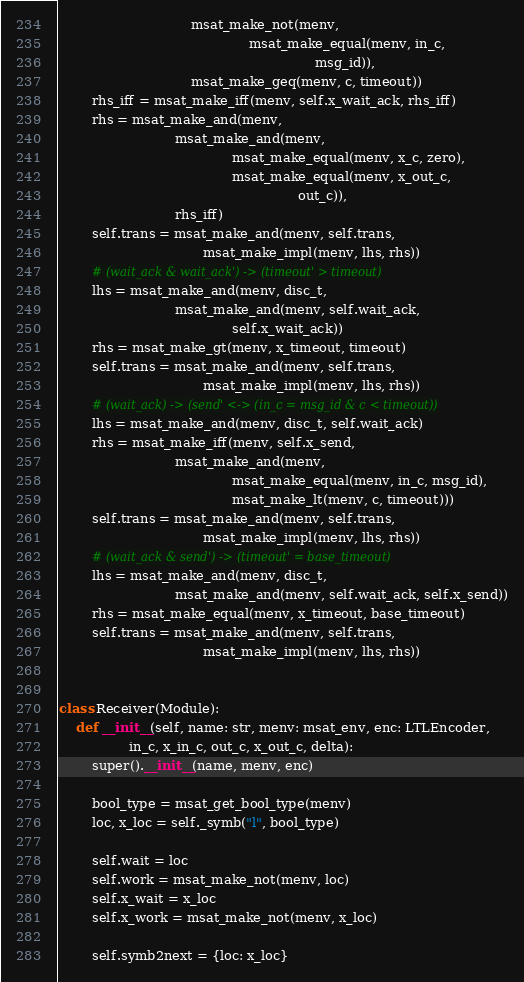Convert code to text. <code><loc_0><loc_0><loc_500><loc_500><_Python_>                                msat_make_not(menv,
                                              msat_make_equal(menv, in_c,
                                                              msg_id)),
                                msat_make_geq(menv, c, timeout))
        rhs_iff = msat_make_iff(menv, self.x_wait_ack, rhs_iff)
        rhs = msat_make_and(menv,
                            msat_make_and(menv,
                                          msat_make_equal(menv, x_c, zero),
                                          msat_make_equal(menv, x_out_c,
                                                          out_c)),
                            rhs_iff)
        self.trans = msat_make_and(menv, self.trans,
                                   msat_make_impl(menv, lhs, rhs))
        # (wait_ack & wait_ack') -> (timeout' > timeout)
        lhs = msat_make_and(menv, disc_t,
                            msat_make_and(menv, self.wait_ack,
                                          self.x_wait_ack))
        rhs = msat_make_gt(menv, x_timeout, timeout)
        self.trans = msat_make_and(menv, self.trans,
                                   msat_make_impl(menv, lhs, rhs))
        # (wait_ack) -> (send' <-> (in_c = msg_id & c < timeout))
        lhs = msat_make_and(menv, disc_t, self.wait_ack)
        rhs = msat_make_iff(menv, self.x_send,
                            msat_make_and(menv,
                                          msat_make_equal(menv, in_c, msg_id),
                                          msat_make_lt(menv, c, timeout)))
        self.trans = msat_make_and(menv, self.trans,
                                   msat_make_impl(menv, lhs, rhs))
        # (wait_ack & send') -> (timeout' = base_timeout)
        lhs = msat_make_and(menv, disc_t,
                            msat_make_and(menv, self.wait_ack, self.x_send))
        rhs = msat_make_equal(menv, x_timeout, base_timeout)
        self.trans = msat_make_and(menv, self.trans,
                                   msat_make_impl(menv, lhs, rhs))


class Receiver(Module):
    def __init__(self, name: str, menv: msat_env, enc: LTLEncoder,
                 in_c, x_in_c, out_c, x_out_c, delta):
        super().__init__(name, menv, enc)

        bool_type = msat_get_bool_type(menv)
        loc, x_loc = self._symb("l", bool_type)

        self.wait = loc
        self.work = msat_make_not(menv, loc)
        self.x_wait = x_loc
        self.x_work = msat_make_not(menv, x_loc)

        self.symb2next = {loc: x_loc}
</code> 